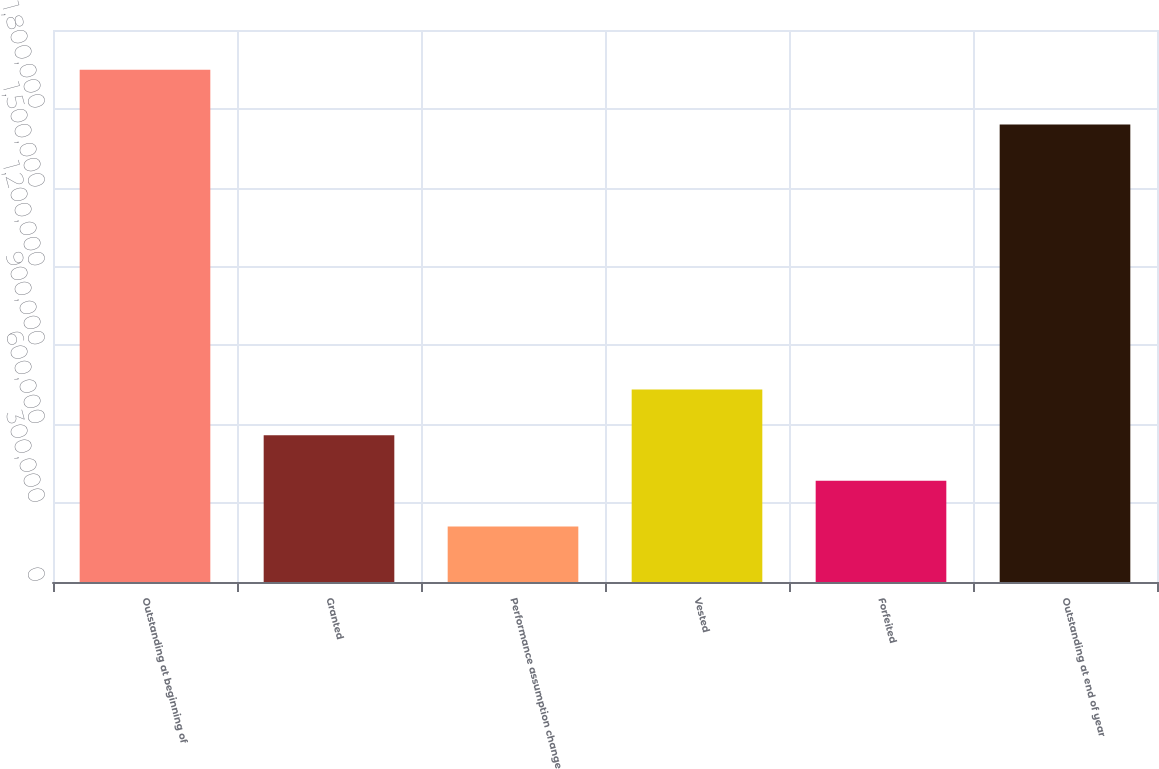Convert chart to OTSL. <chart><loc_0><loc_0><loc_500><loc_500><bar_chart><fcel>Outstanding at beginning of<fcel>Granted<fcel>Performance assumption change<fcel>Vested<fcel>Forfeited<fcel>Outstanding at end of year<nl><fcel>1.94876e+06<fcel>558612<fcel>211076<fcel>732381<fcel>384844<fcel>1.74048e+06<nl></chart> 